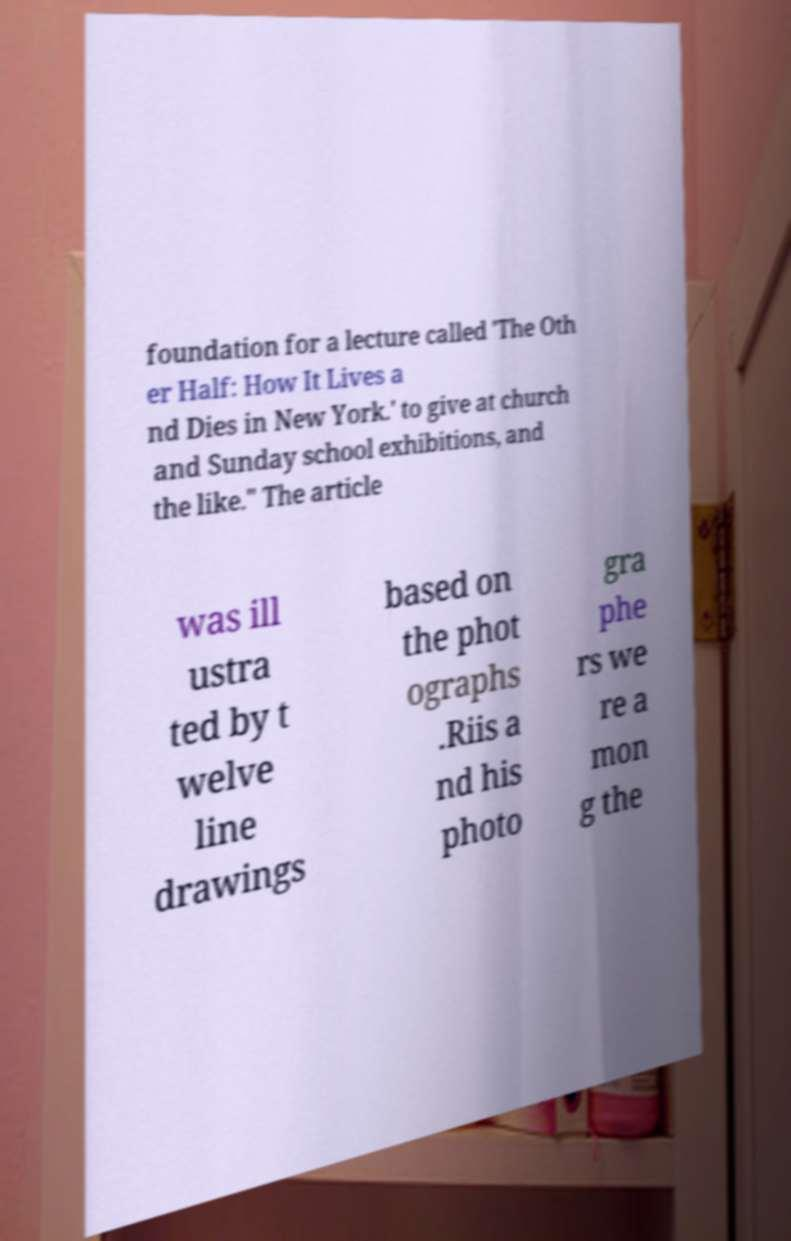I need the written content from this picture converted into text. Can you do that? foundation for a lecture called 'The Oth er Half: How It Lives a nd Dies in New York.' to give at church and Sunday school exhibitions, and the like." The article was ill ustra ted by t welve line drawings based on the phot ographs .Riis a nd his photo gra phe rs we re a mon g the 